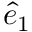Convert formula to latex. <formula><loc_0><loc_0><loc_500><loc_500>\hat { e } _ { 1 }</formula> 